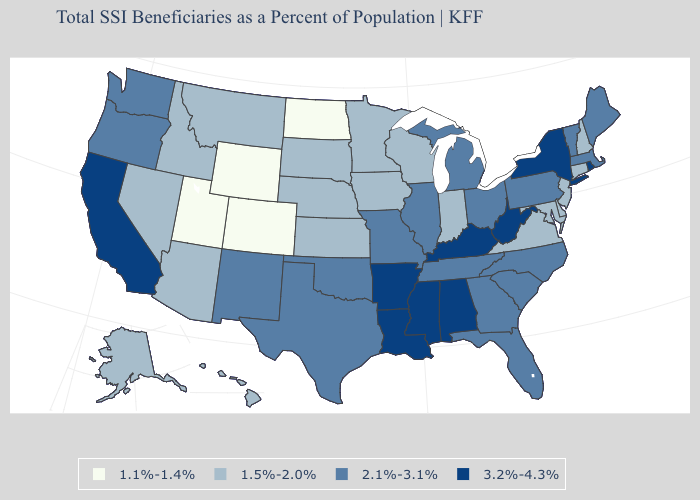Does Maryland have a lower value than Mississippi?
Short answer required. Yes. Name the states that have a value in the range 1.1%-1.4%?
Concise answer only. Colorado, North Dakota, Utah, Wyoming. Among the states that border Louisiana , which have the highest value?
Answer briefly. Arkansas, Mississippi. Among the states that border Michigan , which have the highest value?
Concise answer only. Ohio. Name the states that have a value in the range 2.1%-3.1%?
Write a very short answer. Florida, Georgia, Illinois, Maine, Massachusetts, Michigan, Missouri, New Mexico, North Carolina, Ohio, Oklahoma, Oregon, Pennsylvania, South Carolina, Tennessee, Texas, Vermont, Washington. Does Utah have the same value as Connecticut?
Keep it brief. No. Name the states that have a value in the range 2.1%-3.1%?
Write a very short answer. Florida, Georgia, Illinois, Maine, Massachusetts, Michigan, Missouri, New Mexico, North Carolina, Ohio, Oklahoma, Oregon, Pennsylvania, South Carolina, Tennessee, Texas, Vermont, Washington. Among the states that border Pennsylvania , does New York have the highest value?
Quick response, please. Yes. What is the value of West Virginia?
Answer briefly. 3.2%-4.3%. Name the states that have a value in the range 1.5%-2.0%?
Short answer required. Alaska, Arizona, Connecticut, Delaware, Hawaii, Idaho, Indiana, Iowa, Kansas, Maryland, Minnesota, Montana, Nebraska, Nevada, New Hampshire, New Jersey, South Dakota, Virginia, Wisconsin. Name the states that have a value in the range 1.1%-1.4%?
Concise answer only. Colorado, North Dakota, Utah, Wyoming. Name the states that have a value in the range 1.5%-2.0%?
Short answer required. Alaska, Arizona, Connecticut, Delaware, Hawaii, Idaho, Indiana, Iowa, Kansas, Maryland, Minnesota, Montana, Nebraska, Nevada, New Hampshire, New Jersey, South Dakota, Virginia, Wisconsin. Name the states that have a value in the range 1.5%-2.0%?
Concise answer only. Alaska, Arizona, Connecticut, Delaware, Hawaii, Idaho, Indiana, Iowa, Kansas, Maryland, Minnesota, Montana, Nebraska, Nevada, New Hampshire, New Jersey, South Dakota, Virginia, Wisconsin. Does Oregon have the highest value in the USA?
Quick response, please. No. What is the value of Georgia?
Write a very short answer. 2.1%-3.1%. 